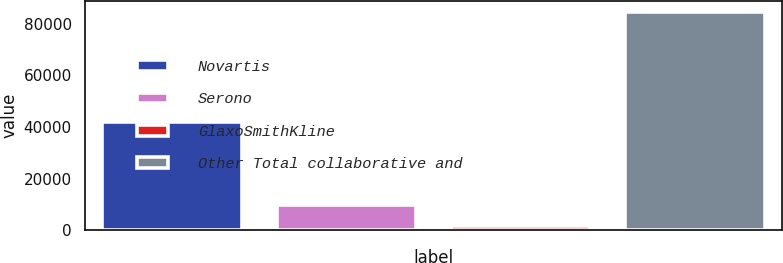Convert chart to OTSL. <chart><loc_0><loc_0><loc_500><loc_500><bar_chart><fcel>Novartis<fcel>Serono<fcel>GlaxoSmithKline<fcel>Other Total collaborative and<nl><fcel>41894<fcel>9821.6<fcel>1500<fcel>84716<nl></chart> 